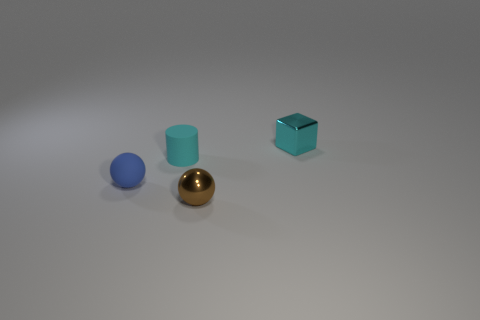Can you describe the materials and appearances of the objects in the scene? Certainly! There are four objects with distinct materials. Starting from left, we have a small blue rubber sphere with a matte finish. Next is a larger teal rubber cylinder, also with a matte surface. Then there's a reflective golden sphere likely made of metal given its shine. Lastly, on the right is a cyan metal cube with a glossy finish reflecting some light, which suggests it is likely made of a polished metal. 